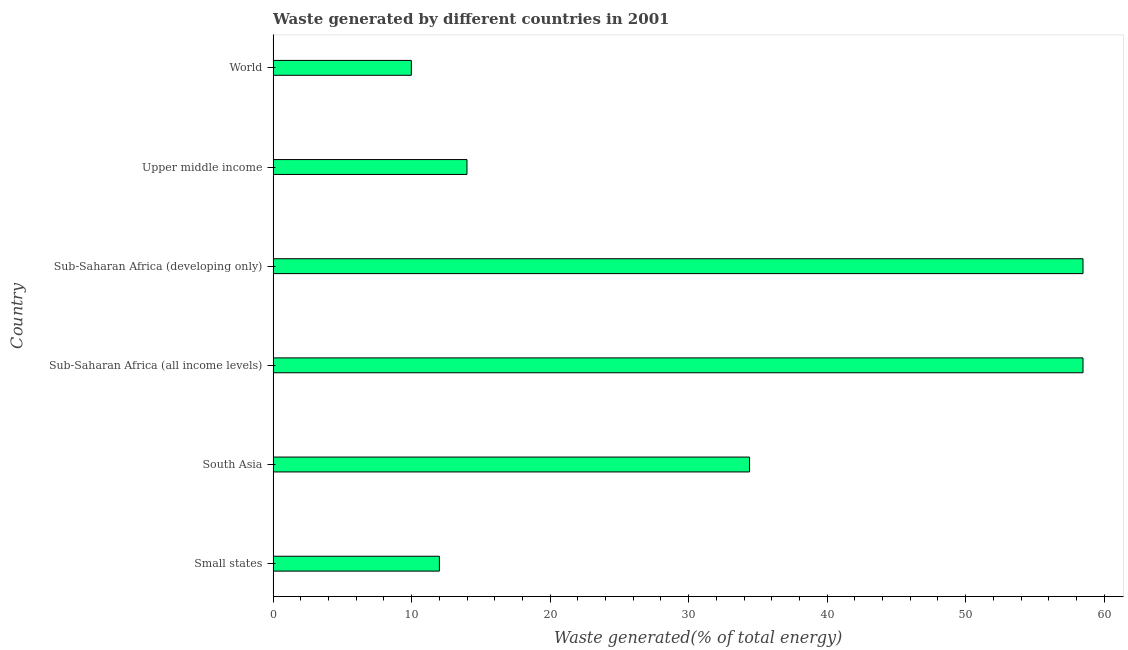Does the graph contain any zero values?
Your answer should be compact. No. Does the graph contain grids?
Make the answer very short. No. What is the title of the graph?
Provide a succinct answer. Waste generated by different countries in 2001. What is the label or title of the X-axis?
Offer a very short reply. Waste generated(% of total energy). What is the amount of waste generated in Upper middle income?
Offer a very short reply. 14. Across all countries, what is the maximum amount of waste generated?
Make the answer very short. 58.47. Across all countries, what is the minimum amount of waste generated?
Make the answer very short. 9.98. In which country was the amount of waste generated maximum?
Keep it short and to the point. Sub-Saharan Africa (all income levels). In which country was the amount of waste generated minimum?
Ensure brevity in your answer.  World. What is the sum of the amount of waste generated?
Keep it short and to the point. 187.32. What is the difference between the amount of waste generated in South Asia and Sub-Saharan Africa (developing only)?
Offer a very short reply. -24.07. What is the average amount of waste generated per country?
Give a very brief answer. 31.22. What is the median amount of waste generated?
Provide a succinct answer. 24.2. What is the ratio of the amount of waste generated in Small states to that in World?
Your response must be concise. 1.2. Is the sum of the amount of waste generated in South Asia and Sub-Saharan Africa (all income levels) greater than the maximum amount of waste generated across all countries?
Make the answer very short. Yes. What is the difference between the highest and the lowest amount of waste generated?
Make the answer very short. 48.49. Are all the bars in the graph horizontal?
Provide a short and direct response. Yes. What is the difference between two consecutive major ticks on the X-axis?
Offer a very short reply. 10. What is the Waste generated(% of total energy) in Small states?
Offer a terse response. 12. What is the Waste generated(% of total energy) of South Asia?
Your answer should be very brief. 34.4. What is the Waste generated(% of total energy) in Sub-Saharan Africa (all income levels)?
Your answer should be very brief. 58.47. What is the Waste generated(% of total energy) of Sub-Saharan Africa (developing only)?
Keep it short and to the point. 58.47. What is the Waste generated(% of total energy) in Upper middle income?
Give a very brief answer. 14. What is the Waste generated(% of total energy) in World?
Your answer should be compact. 9.98. What is the difference between the Waste generated(% of total energy) in Small states and South Asia?
Offer a terse response. -22.39. What is the difference between the Waste generated(% of total energy) in Small states and Sub-Saharan Africa (all income levels)?
Ensure brevity in your answer.  -46.47. What is the difference between the Waste generated(% of total energy) in Small states and Sub-Saharan Africa (developing only)?
Ensure brevity in your answer.  -46.47. What is the difference between the Waste generated(% of total energy) in Small states and Upper middle income?
Ensure brevity in your answer.  -1.99. What is the difference between the Waste generated(% of total energy) in Small states and World?
Offer a terse response. 2.03. What is the difference between the Waste generated(% of total energy) in South Asia and Sub-Saharan Africa (all income levels)?
Make the answer very short. -24.07. What is the difference between the Waste generated(% of total energy) in South Asia and Sub-Saharan Africa (developing only)?
Give a very brief answer. -24.07. What is the difference between the Waste generated(% of total energy) in South Asia and Upper middle income?
Provide a short and direct response. 20.4. What is the difference between the Waste generated(% of total energy) in South Asia and World?
Make the answer very short. 24.42. What is the difference between the Waste generated(% of total energy) in Sub-Saharan Africa (all income levels) and Sub-Saharan Africa (developing only)?
Your response must be concise. 0. What is the difference between the Waste generated(% of total energy) in Sub-Saharan Africa (all income levels) and Upper middle income?
Give a very brief answer. 44.48. What is the difference between the Waste generated(% of total energy) in Sub-Saharan Africa (all income levels) and World?
Your answer should be compact. 48.49. What is the difference between the Waste generated(% of total energy) in Sub-Saharan Africa (developing only) and Upper middle income?
Offer a terse response. 44.48. What is the difference between the Waste generated(% of total energy) in Sub-Saharan Africa (developing only) and World?
Your answer should be very brief. 48.49. What is the difference between the Waste generated(% of total energy) in Upper middle income and World?
Your answer should be very brief. 4.02. What is the ratio of the Waste generated(% of total energy) in Small states to that in South Asia?
Your answer should be very brief. 0.35. What is the ratio of the Waste generated(% of total energy) in Small states to that in Sub-Saharan Africa (all income levels)?
Your answer should be compact. 0.2. What is the ratio of the Waste generated(% of total energy) in Small states to that in Sub-Saharan Africa (developing only)?
Ensure brevity in your answer.  0.2. What is the ratio of the Waste generated(% of total energy) in Small states to that in Upper middle income?
Offer a terse response. 0.86. What is the ratio of the Waste generated(% of total energy) in Small states to that in World?
Your answer should be very brief. 1.2. What is the ratio of the Waste generated(% of total energy) in South Asia to that in Sub-Saharan Africa (all income levels)?
Provide a short and direct response. 0.59. What is the ratio of the Waste generated(% of total energy) in South Asia to that in Sub-Saharan Africa (developing only)?
Your answer should be compact. 0.59. What is the ratio of the Waste generated(% of total energy) in South Asia to that in Upper middle income?
Make the answer very short. 2.46. What is the ratio of the Waste generated(% of total energy) in South Asia to that in World?
Your answer should be compact. 3.45. What is the ratio of the Waste generated(% of total energy) in Sub-Saharan Africa (all income levels) to that in Sub-Saharan Africa (developing only)?
Offer a very short reply. 1. What is the ratio of the Waste generated(% of total energy) in Sub-Saharan Africa (all income levels) to that in Upper middle income?
Offer a terse response. 4.18. What is the ratio of the Waste generated(% of total energy) in Sub-Saharan Africa (all income levels) to that in World?
Your response must be concise. 5.86. What is the ratio of the Waste generated(% of total energy) in Sub-Saharan Africa (developing only) to that in Upper middle income?
Make the answer very short. 4.18. What is the ratio of the Waste generated(% of total energy) in Sub-Saharan Africa (developing only) to that in World?
Offer a very short reply. 5.86. What is the ratio of the Waste generated(% of total energy) in Upper middle income to that in World?
Your answer should be very brief. 1.4. 